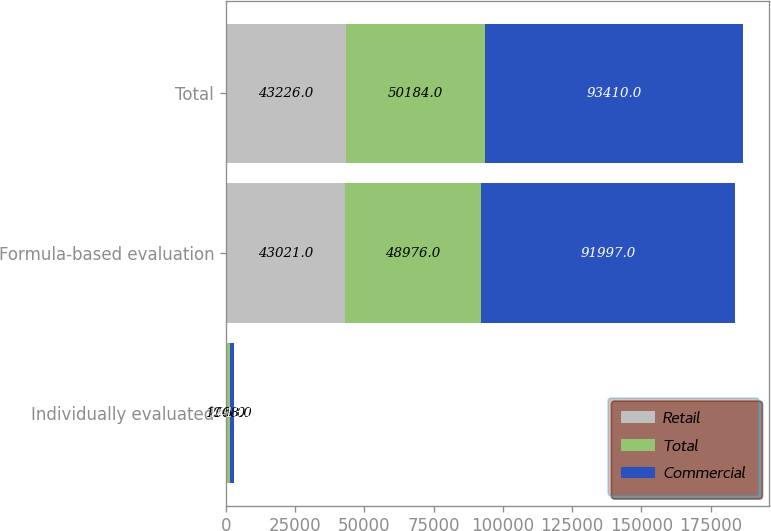Convert chart to OTSL. <chart><loc_0><loc_0><loc_500><loc_500><stacked_bar_chart><ecel><fcel>Individually evaluated<fcel>Formula-based evaluation<fcel>Total<nl><fcel>Retail<fcel>205<fcel>43021<fcel>43226<nl><fcel>Total<fcel>1208<fcel>48976<fcel>50184<nl><fcel>Commercial<fcel>1413<fcel>91997<fcel>93410<nl></chart> 